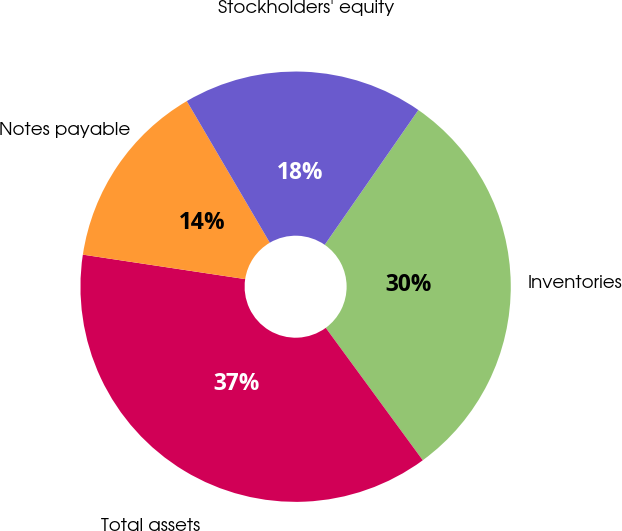<chart> <loc_0><loc_0><loc_500><loc_500><pie_chart><fcel>Inventories<fcel>Total assets<fcel>Notes payable<fcel>Stockholders' equity<nl><fcel>30.27%<fcel>37.44%<fcel>14.18%<fcel>18.1%<nl></chart> 